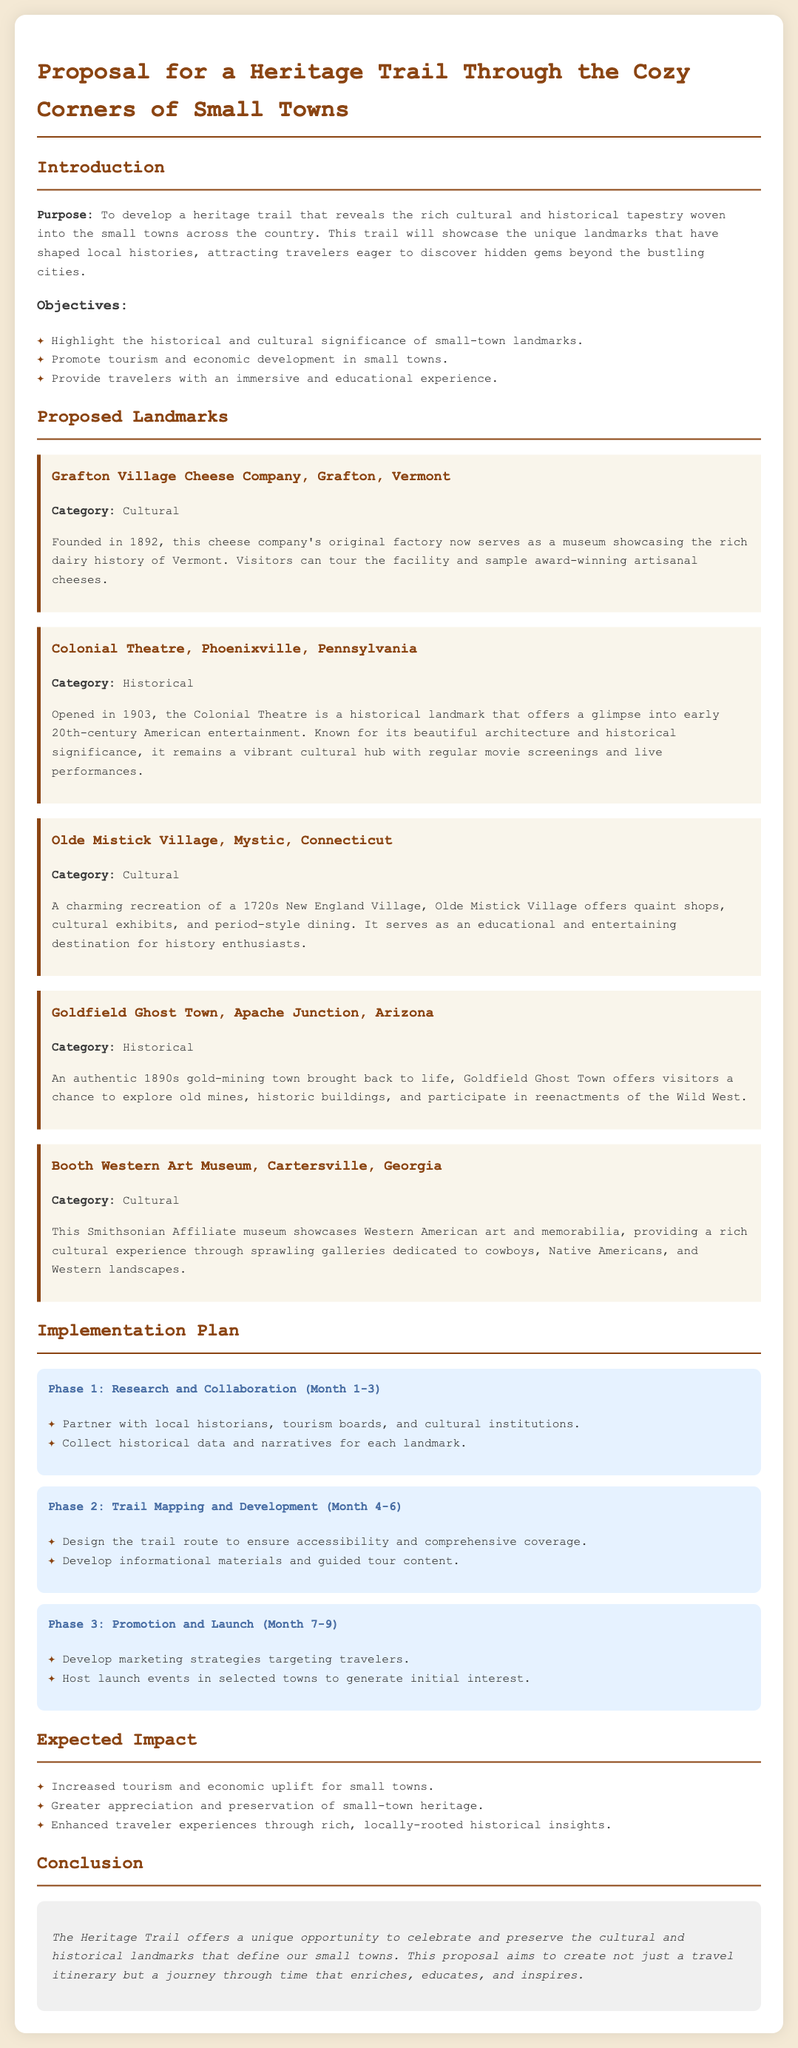what is the purpose of the proposal? The purpose is to develop a heritage trail that reveals the rich cultural and historical tapestry woven into the small towns.
Answer: To develop a heritage trail how many phases are there in the implementation plan? The implementation plan is divided into three distinct phases.
Answer: Three name one of the proposed landmarks. The proposed landmarks include notable locations with cultural and historical significance.
Answer: Grafton Village Cheese Company what year was the Colonial Theatre opened? The text specifies the opening year of the Colonial Theatre as part of its historical background.
Answer: 1903 what is the expected impact regarding tourism? The document mentions the expected impact of increased visitation and economic uplift from tourism.
Answer: Increased tourism which museum is a Smithsonian Affiliate? The proposal identifies a specific museum that aligns with the Smithsonian's network.
Answer: Booth Western Art Museum 